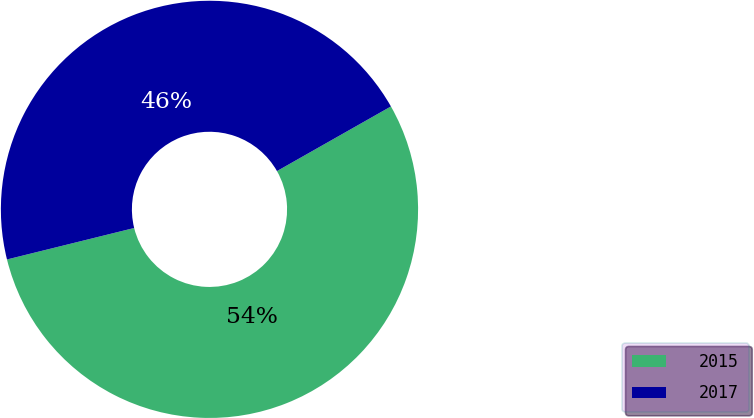Convert chart. <chart><loc_0><loc_0><loc_500><loc_500><pie_chart><fcel>2015<fcel>2017<nl><fcel>54.35%<fcel>45.65%<nl></chart> 